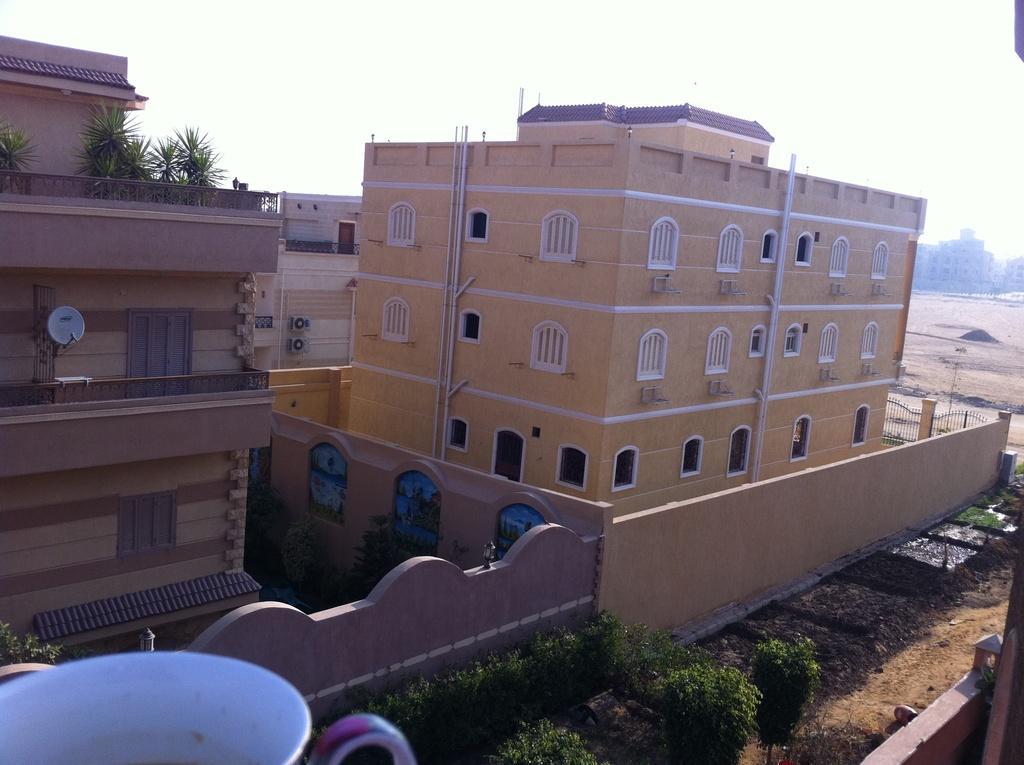Can you describe this image briefly? In this picture we can see few trees, buildings, lights and few pipes on the walls, in the bottom left hand corner we can see a cup. 